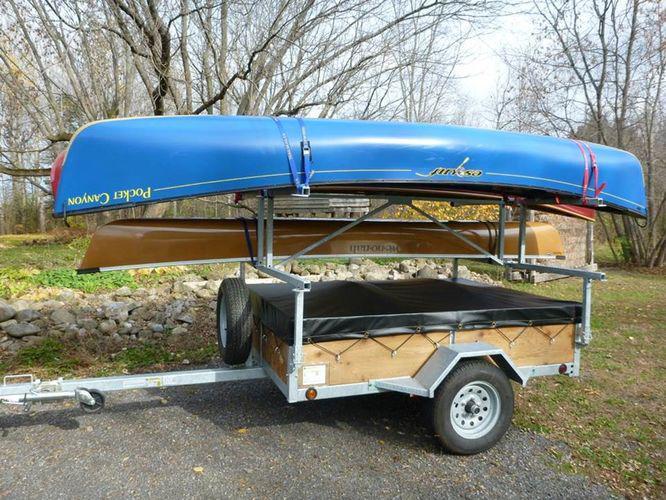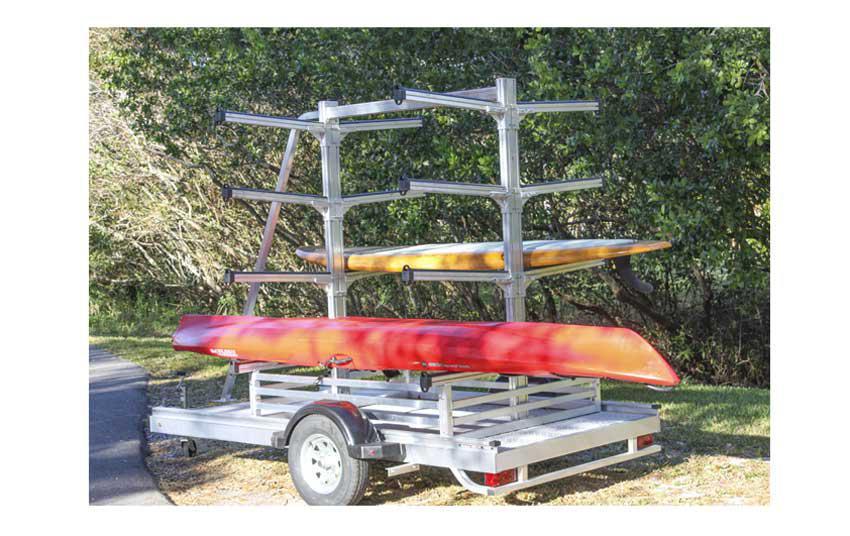The first image is the image on the left, the second image is the image on the right. For the images shown, is this caption "In the image to the left, we have boats of yellow color, red color, and also blue color." true? Answer yes or no. No. The first image is the image on the left, the second image is the image on the right. For the images shown, is this caption "Each image includes a rack containing at least three boats in bright solid colors." true? Answer yes or no. No. 